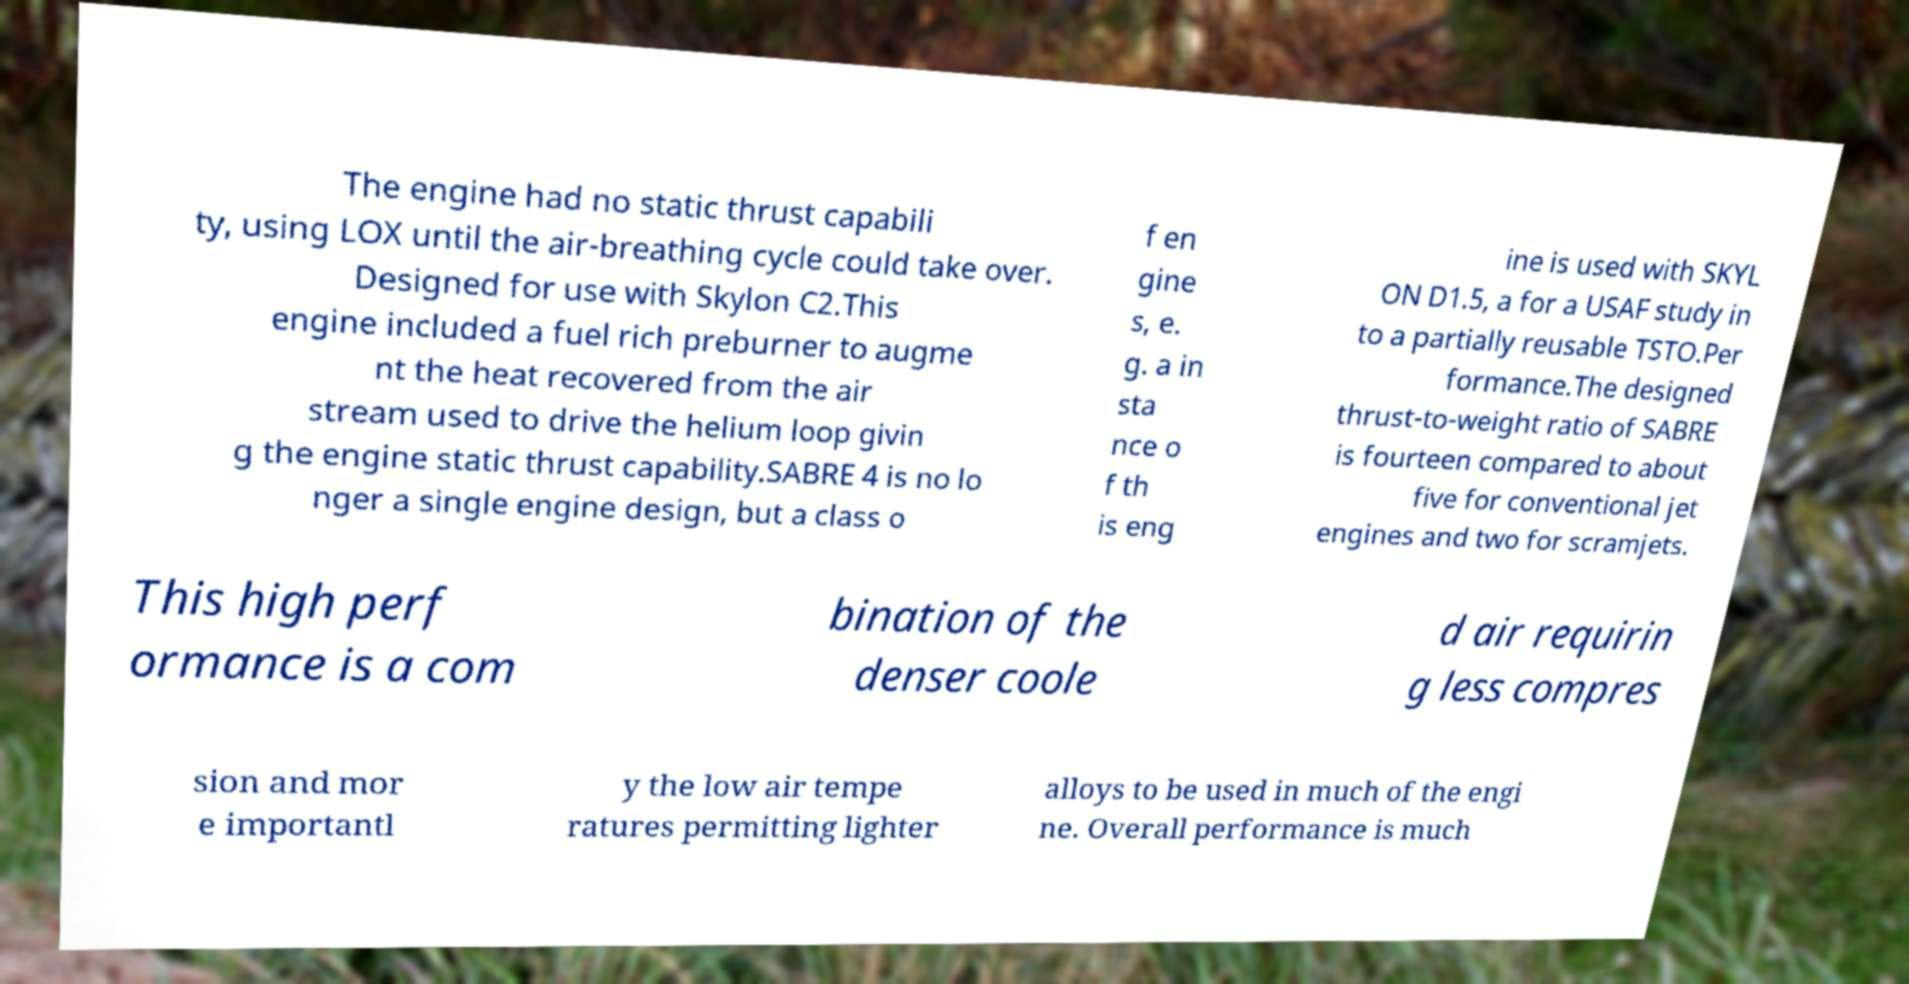I need the written content from this picture converted into text. Can you do that? The engine had no static thrust capabili ty, using LOX until the air-breathing cycle could take over. Designed for use with Skylon C2.This engine included a fuel rich preburner to augme nt the heat recovered from the air stream used to drive the helium loop givin g the engine static thrust capability.SABRE 4 is no lo nger a single engine design, but a class o f en gine s, e. g. a in sta nce o f th is eng ine is used with SKYL ON D1.5, a for a USAF study in to a partially reusable TSTO.Per formance.The designed thrust-to-weight ratio of SABRE is fourteen compared to about five for conventional jet engines and two for scramjets. This high perf ormance is a com bination of the denser coole d air requirin g less compres sion and mor e importantl y the low air tempe ratures permitting lighter alloys to be used in much of the engi ne. Overall performance is much 